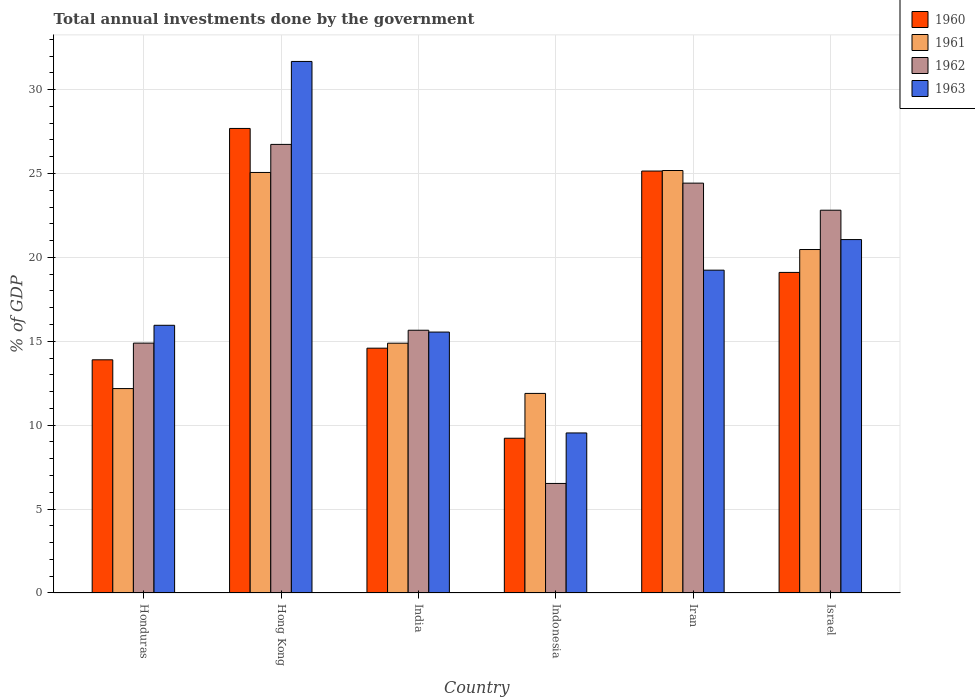How many different coloured bars are there?
Keep it short and to the point. 4. Are the number of bars per tick equal to the number of legend labels?
Give a very brief answer. Yes. Are the number of bars on each tick of the X-axis equal?
Make the answer very short. Yes. How many bars are there on the 3rd tick from the left?
Offer a terse response. 4. How many bars are there on the 1st tick from the right?
Your answer should be compact. 4. In how many cases, is the number of bars for a given country not equal to the number of legend labels?
Your response must be concise. 0. What is the total annual investments done by the government in 1962 in Iran?
Offer a very short reply. 24.43. Across all countries, what is the maximum total annual investments done by the government in 1963?
Make the answer very short. 31.68. Across all countries, what is the minimum total annual investments done by the government in 1960?
Provide a short and direct response. 9.22. In which country was the total annual investments done by the government in 1963 maximum?
Your response must be concise. Hong Kong. In which country was the total annual investments done by the government in 1963 minimum?
Provide a short and direct response. Indonesia. What is the total total annual investments done by the government in 1963 in the graph?
Offer a very short reply. 113.04. What is the difference between the total annual investments done by the government in 1961 in Iran and that in Israel?
Make the answer very short. 4.71. What is the difference between the total annual investments done by the government in 1961 in Indonesia and the total annual investments done by the government in 1960 in Honduras?
Provide a succinct answer. -2. What is the average total annual investments done by the government in 1962 per country?
Offer a terse response. 18.51. What is the difference between the total annual investments done by the government of/in 1961 and total annual investments done by the government of/in 1962 in Iran?
Offer a terse response. 0.75. What is the ratio of the total annual investments done by the government in 1962 in Honduras to that in Hong Kong?
Ensure brevity in your answer.  0.56. Is the difference between the total annual investments done by the government in 1961 in India and Indonesia greater than the difference between the total annual investments done by the government in 1962 in India and Indonesia?
Make the answer very short. No. What is the difference between the highest and the second highest total annual investments done by the government in 1962?
Provide a succinct answer. -2.31. What is the difference between the highest and the lowest total annual investments done by the government in 1963?
Make the answer very short. 22.14. Is the sum of the total annual investments done by the government in 1962 in Honduras and Hong Kong greater than the maximum total annual investments done by the government in 1963 across all countries?
Make the answer very short. Yes. Is it the case that in every country, the sum of the total annual investments done by the government in 1962 and total annual investments done by the government in 1963 is greater than the sum of total annual investments done by the government in 1961 and total annual investments done by the government in 1960?
Your response must be concise. No. Are all the bars in the graph horizontal?
Your answer should be very brief. No. How many countries are there in the graph?
Provide a short and direct response. 6. What is the difference between two consecutive major ticks on the Y-axis?
Provide a short and direct response. 5. Are the values on the major ticks of Y-axis written in scientific E-notation?
Offer a very short reply. No. Does the graph contain any zero values?
Offer a very short reply. No. Does the graph contain grids?
Provide a succinct answer. Yes. What is the title of the graph?
Offer a terse response. Total annual investments done by the government. Does "1989" appear as one of the legend labels in the graph?
Keep it short and to the point. No. What is the label or title of the X-axis?
Keep it short and to the point. Country. What is the label or title of the Y-axis?
Your answer should be very brief. % of GDP. What is the % of GDP of 1960 in Honduras?
Offer a very short reply. 13.9. What is the % of GDP in 1961 in Honduras?
Ensure brevity in your answer.  12.18. What is the % of GDP in 1962 in Honduras?
Your answer should be compact. 14.89. What is the % of GDP of 1963 in Honduras?
Provide a short and direct response. 15.96. What is the % of GDP of 1960 in Hong Kong?
Provide a short and direct response. 27.69. What is the % of GDP of 1961 in Hong Kong?
Your response must be concise. 25.06. What is the % of GDP of 1962 in Hong Kong?
Your answer should be very brief. 26.74. What is the % of GDP of 1963 in Hong Kong?
Provide a short and direct response. 31.68. What is the % of GDP of 1960 in India?
Keep it short and to the point. 14.59. What is the % of GDP of 1961 in India?
Make the answer very short. 14.89. What is the % of GDP in 1962 in India?
Make the answer very short. 15.66. What is the % of GDP of 1963 in India?
Offer a very short reply. 15.55. What is the % of GDP of 1960 in Indonesia?
Give a very brief answer. 9.22. What is the % of GDP in 1961 in Indonesia?
Keep it short and to the point. 11.9. What is the % of GDP in 1962 in Indonesia?
Your response must be concise. 6.53. What is the % of GDP in 1963 in Indonesia?
Keep it short and to the point. 9.54. What is the % of GDP in 1960 in Iran?
Make the answer very short. 25.15. What is the % of GDP in 1961 in Iran?
Provide a succinct answer. 25.18. What is the % of GDP in 1962 in Iran?
Your answer should be compact. 24.43. What is the % of GDP in 1963 in Iran?
Provide a succinct answer. 19.24. What is the % of GDP of 1960 in Israel?
Your answer should be compact. 19.11. What is the % of GDP of 1961 in Israel?
Your answer should be very brief. 20.47. What is the % of GDP in 1962 in Israel?
Your answer should be very brief. 22.82. What is the % of GDP in 1963 in Israel?
Provide a short and direct response. 21.06. Across all countries, what is the maximum % of GDP in 1960?
Your answer should be very brief. 27.69. Across all countries, what is the maximum % of GDP of 1961?
Your answer should be compact. 25.18. Across all countries, what is the maximum % of GDP in 1962?
Provide a succinct answer. 26.74. Across all countries, what is the maximum % of GDP of 1963?
Give a very brief answer. 31.68. Across all countries, what is the minimum % of GDP in 1960?
Your answer should be very brief. 9.22. Across all countries, what is the minimum % of GDP in 1961?
Provide a succinct answer. 11.9. Across all countries, what is the minimum % of GDP in 1962?
Provide a short and direct response. 6.53. Across all countries, what is the minimum % of GDP of 1963?
Offer a very short reply. 9.54. What is the total % of GDP of 1960 in the graph?
Offer a terse response. 109.66. What is the total % of GDP in 1961 in the graph?
Offer a very short reply. 109.69. What is the total % of GDP in 1962 in the graph?
Give a very brief answer. 111.07. What is the total % of GDP of 1963 in the graph?
Keep it short and to the point. 113.04. What is the difference between the % of GDP in 1960 in Honduras and that in Hong Kong?
Make the answer very short. -13.79. What is the difference between the % of GDP in 1961 in Honduras and that in Hong Kong?
Your answer should be compact. -12.88. What is the difference between the % of GDP of 1962 in Honduras and that in Hong Kong?
Your response must be concise. -11.84. What is the difference between the % of GDP of 1963 in Honduras and that in Hong Kong?
Ensure brevity in your answer.  -15.73. What is the difference between the % of GDP of 1960 in Honduras and that in India?
Provide a short and direct response. -0.69. What is the difference between the % of GDP in 1961 in Honduras and that in India?
Provide a succinct answer. -2.7. What is the difference between the % of GDP of 1962 in Honduras and that in India?
Your answer should be very brief. -0.77. What is the difference between the % of GDP of 1963 in Honduras and that in India?
Offer a very short reply. 0.4. What is the difference between the % of GDP of 1960 in Honduras and that in Indonesia?
Offer a very short reply. 4.68. What is the difference between the % of GDP in 1961 in Honduras and that in Indonesia?
Give a very brief answer. 0.29. What is the difference between the % of GDP in 1962 in Honduras and that in Indonesia?
Keep it short and to the point. 8.36. What is the difference between the % of GDP in 1963 in Honduras and that in Indonesia?
Provide a succinct answer. 6.42. What is the difference between the % of GDP of 1960 in Honduras and that in Iran?
Provide a succinct answer. -11.25. What is the difference between the % of GDP of 1961 in Honduras and that in Iran?
Keep it short and to the point. -13. What is the difference between the % of GDP of 1962 in Honduras and that in Iran?
Your answer should be very brief. -9.54. What is the difference between the % of GDP in 1963 in Honduras and that in Iran?
Your answer should be compact. -3.29. What is the difference between the % of GDP in 1960 in Honduras and that in Israel?
Provide a short and direct response. -5.21. What is the difference between the % of GDP in 1961 in Honduras and that in Israel?
Give a very brief answer. -8.29. What is the difference between the % of GDP in 1962 in Honduras and that in Israel?
Give a very brief answer. -7.92. What is the difference between the % of GDP of 1963 in Honduras and that in Israel?
Your answer should be very brief. -5.11. What is the difference between the % of GDP in 1960 in Hong Kong and that in India?
Offer a terse response. 13.1. What is the difference between the % of GDP of 1961 in Hong Kong and that in India?
Offer a very short reply. 10.18. What is the difference between the % of GDP of 1962 in Hong Kong and that in India?
Offer a terse response. 11.08. What is the difference between the % of GDP of 1963 in Hong Kong and that in India?
Your response must be concise. 16.13. What is the difference between the % of GDP of 1960 in Hong Kong and that in Indonesia?
Give a very brief answer. 18.47. What is the difference between the % of GDP of 1961 in Hong Kong and that in Indonesia?
Make the answer very short. 13.17. What is the difference between the % of GDP in 1962 in Hong Kong and that in Indonesia?
Keep it short and to the point. 20.21. What is the difference between the % of GDP in 1963 in Hong Kong and that in Indonesia?
Your response must be concise. 22.14. What is the difference between the % of GDP of 1960 in Hong Kong and that in Iran?
Keep it short and to the point. 2.54. What is the difference between the % of GDP in 1961 in Hong Kong and that in Iran?
Your answer should be very brief. -0.12. What is the difference between the % of GDP of 1962 in Hong Kong and that in Iran?
Offer a very short reply. 2.31. What is the difference between the % of GDP in 1963 in Hong Kong and that in Iran?
Your answer should be compact. 12.44. What is the difference between the % of GDP of 1960 in Hong Kong and that in Israel?
Provide a short and direct response. 8.58. What is the difference between the % of GDP in 1961 in Hong Kong and that in Israel?
Keep it short and to the point. 4.59. What is the difference between the % of GDP of 1962 in Hong Kong and that in Israel?
Provide a succinct answer. 3.92. What is the difference between the % of GDP of 1963 in Hong Kong and that in Israel?
Your answer should be very brief. 10.62. What is the difference between the % of GDP of 1960 in India and that in Indonesia?
Make the answer very short. 5.37. What is the difference between the % of GDP in 1961 in India and that in Indonesia?
Provide a succinct answer. 2.99. What is the difference between the % of GDP in 1962 in India and that in Indonesia?
Provide a short and direct response. 9.13. What is the difference between the % of GDP of 1963 in India and that in Indonesia?
Keep it short and to the point. 6.01. What is the difference between the % of GDP in 1960 in India and that in Iran?
Give a very brief answer. -10.56. What is the difference between the % of GDP in 1961 in India and that in Iran?
Keep it short and to the point. -10.29. What is the difference between the % of GDP of 1962 in India and that in Iran?
Provide a short and direct response. -8.77. What is the difference between the % of GDP in 1963 in India and that in Iran?
Offer a very short reply. -3.69. What is the difference between the % of GDP in 1960 in India and that in Israel?
Your response must be concise. -4.52. What is the difference between the % of GDP in 1961 in India and that in Israel?
Provide a short and direct response. -5.58. What is the difference between the % of GDP of 1962 in India and that in Israel?
Offer a very short reply. -7.15. What is the difference between the % of GDP of 1963 in India and that in Israel?
Provide a short and direct response. -5.51. What is the difference between the % of GDP of 1960 in Indonesia and that in Iran?
Ensure brevity in your answer.  -15.93. What is the difference between the % of GDP of 1961 in Indonesia and that in Iran?
Offer a very short reply. -13.29. What is the difference between the % of GDP of 1962 in Indonesia and that in Iran?
Your response must be concise. -17.9. What is the difference between the % of GDP of 1963 in Indonesia and that in Iran?
Ensure brevity in your answer.  -9.7. What is the difference between the % of GDP of 1960 in Indonesia and that in Israel?
Offer a very short reply. -9.88. What is the difference between the % of GDP of 1961 in Indonesia and that in Israel?
Provide a succinct answer. -8.58. What is the difference between the % of GDP in 1962 in Indonesia and that in Israel?
Your answer should be compact. -16.29. What is the difference between the % of GDP in 1963 in Indonesia and that in Israel?
Your answer should be compact. -11.53. What is the difference between the % of GDP of 1960 in Iran and that in Israel?
Keep it short and to the point. 6.04. What is the difference between the % of GDP in 1961 in Iran and that in Israel?
Ensure brevity in your answer.  4.71. What is the difference between the % of GDP in 1962 in Iran and that in Israel?
Make the answer very short. 1.61. What is the difference between the % of GDP of 1963 in Iran and that in Israel?
Ensure brevity in your answer.  -1.82. What is the difference between the % of GDP in 1960 in Honduras and the % of GDP in 1961 in Hong Kong?
Offer a very short reply. -11.17. What is the difference between the % of GDP in 1960 in Honduras and the % of GDP in 1962 in Hong Kong?
Your answer should be compact. -12.84. What is the difference between the % of GDP in 1960 in Honduras and the % of GDP in 1963 in Hong Kong?
Ensure brevity in your answer.  -17.78. What is the difference between the % of GDP of 1961 in Honduras and the % of GDP of 1962 in Hong Kong?
Make the answer very short. -14.55. What is the difference between the % of GDP of 1961 in Honduras and the % of GDP of 1963 in Hong Kong?
Provide a short and direct response. -19.5. What is the difference between the % of GDP in 1962 in Honduras and the % of GDP in 1963 in Hong Kong?
Offer a very short reply. -16.79. What is the difference between the % of GDP in 1960 in Honduras and the % of GDP in 1961 in India?
Provide a succinct answer. -0.99. What is the difference between the % of GDP in 1960 in Honduras and the % of GDP in 1962 in India?
Give a very brief answer. -1.76. What is the difference between the % of GDP in 1960 in Honduras and the % of GDP in 1963 in India?
Offer a terse response. -1.65. What is the difference between the % of GDP in 1961 in Honduras and the % of GDP in 1962 in India?
Ensure brevity in your answer.  -3.48. What is the difference between the % of GDP in 1961 in Honduras and the % of GDP in 1963 in India?
Your answer should be compact. -3.37. What is the difference between the % of GDP in 1962 in Honduras and the % of GDP in 1963 in India?
Ensure brevity in your answer.  -0.66. What is the difference between the % of GDP in 1960 in Honduras and the % of GDP in 1961 in Indonesia?
Make the answer very short. 2. What is the difference between the % of GDP of 1960 in Honduras and the % of GDP of 1962 in Indonesia?
Offer a terse response. 7.37. What is the difference between the % of GDP of 1960 in Honduras and the % of GDP of 1963 in Indonesia?
Provide a succinct answer. 4.36. What is the difference between the % of GDP in 1961 in Honduras and the % of GDP in 1962 in Indonesia?
Provide a short and direct response. 5.65. What is the difference between the % of GDP in 1961 in Honduras and the % of GDP in 1963 in Indonesia?
Your answer should be compact. 2.64. What is the difference between the % of GDP in 1962 in Honduras and the % of GDP in 1963 in Indonesia?
Ensure brevity in your answer.  5.35. What is the difference between the % of GDP in 1960 in Honduras and the % of GDP in 1961 in Iran?
Your answer should be compact. -11.28. What is the difference between the % of GDP in 1960 in Honduras and the % of GDP in 1962 in Iran?
Offer a terse response. -10.53. What is the difference between the % of GDP of 1960 in Honduras and the % of GDP of 1963 in Iran?
Ensure brevity in your answer.  -5.34. What is the difference between the % of GDP of 1961 in Honduras and the % of GDP of 1962 in Iran?
Keep it short and to the point. -12.24. What is the difference between the % of GDP of 1961 in Honduras and the % of GDP of 1963 in Iran?
Your response must be concise. -7.06. What is the difference between the % of GDP in 1962 in Honduras and the % of GDP in 1963 in Iran?
Make the answer very short. -4.35. What is the difference between the % of GDP in 1960 in Honduras and the % of GDP in 1961 in Israel?
Make the answer very short. -6.57. What is the difference between the % of GDP of 1960 in Honduras and the % of GDP of 1962 in Israel?
Offer a terse response. -8.92. What is the difference between the % of GDP in 1960 in Honduras and the % of GDP in 1963 in Israel?
Provide a short and direct response. -7.17. What is the difference between the % of GDP of 1961 in Honduras and the % of GDP of 1962 in Israel?
Offer a terse response. -10.63. What is the difference between the % of GDP in 1961 in Honduras and the % of GDP in 1963 in Israel?
Give a very brief answer. -8.88. What is the difference between the % of GDP of 1962 in Honduras and the % of GDP of 1963 in Israel?
Your answer should be compact. -6.17. What is the difference between the % of GDP in 1960 in Hong Kong and the % of GDP in 1961 in India?
Your answer should be compact. 12.8. What is the difference between the % of GDP of 1960 in Hong Kong and the % of GDP of 1962 in India?
Offer a very short reply. 12.03. What is the difference between the % of GDP in 1960 in Hong Kong and the % of GDP in 1963 in India?
Offer a terse response. 12.14. What is the difference between the % of GDP of 1961 in Hong Kong and the % of GDP of 1962 in India?
Offer a terse response. 9.4. What is the difference between the % of GDP in 1961 in Hong Kong and the % of GDP in 1963 in India?
Your answer should be compact. 9.51. What is the difference between the % of GDP in 1962 in Hong Kong and the % of GDP in 1963 in India?
Provide a short and direct response. 11.19. What is the difference between the % of GDP in 1960 in Hong Kong and the % of GDP in 1961 in Indonesia?
Provide a short and direct response. 15.79. What is the difference between the % of GDP in 1960 in Hong Kong and the % of GDP in 1962 in Indonesia?
Keep it short and to the point. 21.16. What is the difference between the % of GDP of 1960 in Hong Kong and the % of GDP of 1963 in Indonesia?
Your answer should be very brief. 18.15. What is the difference between the % of GDP in 1961 in Hong Kong and the % of GDP in 1962 in Indonesia?
Provide a succinct answer. 18.54. What is the difference between the % of GDP of 1961 in Hong Kong and the % of GDP of 1963 in Indonesia?
Your answer should be compact. 15.53. What is the difference between the % of GDP in 1962 in Hong Kong and the % of GDP in 1963 in Indonesia?
Provide a succinct answer. 17.2. What is the difference between the % of GDP of 1960 in Hong Kong and the % of GDP of 1961 in Iran?
Give a very brief answer. 2.51. What is the difference between the % of GDP in 1960 in Hong Kong and the % of GDP in 1962 in Iran?
Provide a succinct answer. 3.26. What is the difference between the % of GDP in 1960 in Hong Kong and the % of GDP in 1963 in Iran?
Your answer should be compact. 8.45. What is the difference between the % of GDP in 1961 in Hong Kong and the % of GDP in 1962 in Iran?
Your answer should be compact. 0.64. What is the difference between the % of GDP of 1961 in Hong Kong and the % of GDP of 1963 in Iran?
Your answer should be very brief. 5.82. What is the difference between the % of GDP in 1962 in Hong Kong and the % of GDP in 1963 in Iran?
Ensure brevity in your answer.  7.5. What is the difference between the % of GDP of 1960 in Hong Kong and the % of GDP of 1961 in Israel?
Your answer should be compact. 7.22. What is the difference between the % of GDP of 1960 in Hong Kong and the % of GDP of 1962 in Israel?
Make the answer very short. 4.87. What is the difference between the % of GDP in 1960 in Hong Kong and the % of GDP in 1963 in Israel?
Give a very brief answer. 6.62. What is the difference between the % of GDP of 1961 in Hong Kong and the % of GDP of 1962 in Israel?
Provide a short and direct response. 2.25. What is the difference between the % of GDP in 1961 in Hong Kong and the % of GDP in 1963 in Israel?
Give a very brief answer. 4. What is the difference between the % of GDP of 1962 in Hong Kong and the % of GDP of 1963 in Israel?
Offer a very short reply. 5.67. What is the difference between the % of GDP of 1960 in India and the % of GDP of 1961 in Indonesia?
Ensure brevity in your answer.  2.7. What is the difference between the % of GDP in 1960 in India and the % of GDP in 1962 in Indonesia?
Ensure brevity in your answer.  8.06. What is the difference between the % of GDP of 1960 in India and the % of GDP of 1963 in Indonesia?
Provide a short and direct response. 5.05. What is the difference between the % of GDP in 1961 in India and the % of GDP in 1962 in Indonesia?
Provide a succinct answer. 8.36. What is the difference between the % of GDP of 1961 in India and the % of GDP of 1963 in Indonesia?
Provide a succinct answer. 5.35. What is the difference between the % of GDP in 1962 in India and the % of GDP in 1963 in Indonesia?
Make the answer very short. 6.12. What is the difference between the % of GDP in 1960 in India and the % of GDP in 1961 in Iran?
Your response must be concise. -10.59. What is the difference between the % of GDP in 1960 in India and the % of GDP in 1962 in Iran?
Offer a very short reply. -9.84. What is the difference between the % of GDP in 1960 in India and the % of GDP in 1963 in Iran?
Your response must be concise. -4.65. What is the difference between the % of GDP of 1961 in India and the % of GDP of 1962 in Iran?
Ensure brevity in your answer.  -9.54. What is the difference between the % of GDP in 1961 in India and the % of GDP in 1963 in Iran?
Offer a terse response. -4.35. What is the difference between the % of GDP in 1962 in India and the % of GDP in 1963 in Iran?
Provide a short and direct response. -3.58. What is the difference between the % of GDP in 1960 in India and the % of GDP in 1961 in Israel?
Offer a terse response. -5.88. What is the difference between the % of GDP in 1960 in India and the % of GDP in 1962 in Israel?
Your answer should be very brief. -8.22. What is the difference between the % of GDP of 1960 in India and the % of GDP of 1963 in Israel?
Give a very brief answer. -6.47. What is the difference between the % of GDP of 1961 in India and the % of GDP of 1962 in Israel?
Provide a short and direct response. -7.93. What is the difference between the % of GDP in 1961 in India and the % of GDP in 1963 in Israel?
Ensure brevity in your answer.  -6.18. What is the difference between the % of GDP in 1962 in India and the % of GDP in 1963 in Israel?
Offer a very short reply. -5.4. What is the difference between the % of GDP of 1960 in Indonesia and the % of GDP of 1961 in Iran?
Your answer should be compact. -15.96. What is the difference between the % of GDP in 1960 in Indonesia and the % of GDP in 1962 in Iran?
Provide a short and direct response. -15.21. What is the difference between the % of GDP of 1960 in Indonesia and the % of GDP of 1963 in Iran?
Your answer should be very brief. -10.02. What is the difference between the % of GDP of 1961 in Indonesia and the % of GDP of 1962 in Iran?
Your response must be concise. -12.53. What is the difference between the % of GDP in 1961 in Indonesia and the % of GDP in 1963 in Iran?
Offer a very short reply. -7.35. What is the difference between the % of GDP in 1962 in Indonesia and the % of GDP in 1963 in Iran?
Keep it short and to the point. -12.71. What is the difference between the % of GDP in 1960 in Indonesia and the % of GDP in 1961 in Israel?
Offer a very short reply. -11.25. What is the difference between the % of GDP of 1960 in Indonesia and the % of GDP of 1962 in Israel?
Your answer should be compact. -13.59. What is the difference between the % of GDP of 1960 in Indonesia and the % of GDP of 1963 in Israel?
Provide a short and direct response. -11.84. What is the difference between the % of GDP of 1961 in Indonesia and the % of GDP of 1962 in Israel?
Ensure brevity in your answer.  -10.92. What is the difference between the % of GDP in 1961 in Indonesia and the % of GDP in 1963 in Israel?
Offer a very short reply. -9.17. What is the difference between the % of GDP in 1962 in Indonesia and the % of GDP in 1963 in Israel?
Provide a short and direct response. -14.54. What is the difference between the % of GDP in 1960 in Iran and the % of GDP in 1961 in Israel?
Provide a succinct answer. 4.68. What is the difference between the % of GDP of 1960 in Iran and the % of GDP of 1962 in Israel?
Give a very brief answer. 2.33. What is the difference between the % of GDP of 1960 in Iran and the % of GDP of 1963 in Israel?
Provide a succinct answer. 4.08. What is the difference between the % of GDP of 1961 in Iran and the % of GDP of 1962 in Israel?
Your answer should be very brief. 2.37. What is the difference between the % of GDP of 1961 in Iran and the % of GDP of 1963 in Israel?
Your answer should be compact. 4.12. What is the difference between the % of GDP in 1962 in Iran and the % of GDP in 1963 in Israel?
Give a very brief answer. 3.36. What is the average % of GDP in 1960 per country?
Provide a succinct answer. 18.28. What is the average % of GDP in 1961 per country?
Offer a terse response. 18.28. What is the average % of GDP in 1962 per country?
Your response must be concise. 18.51. What is the average % of GDP of 1963 per country?
Provide a succinct answer. 18.84. What is the difference between the % of GDP in 1960 and % of GDP in 1961 in Honduras?
Keep it short and to the point. 1.71. What is the difference between the % of GDP in 1960 and % of GDP in 1962 in Honduras?
Ensure brevity in your answer.  -1. What is the difference between the % of GDP in 1960 and % of GDP in 1963 in Honduras?
Give a very brief answer. -2.06. What is the difference between the % of GDP in 1961 and % of GDP in 1962 in Honduras?
Offer a terse response. -2.71. What is the difference between the % of GDP of 1961 and % of GDP of 1963 in Honduras?
Offer a very short reply. -3.77. What is the difference between the % of GDP of 1962 and % of GDP of 1963 in Honduras?
Your answer should be very brief. -1.06. What is the difference between the % of GDP in 1960 and % of GDP in 1961 in Hong Kong?
Provide a short and direct response. 2.62. What is the difference between the % of GDP in 1960 and % of GDP in 1962 in Hong Kong?
Your answer should be very brief. 0.95. What is the difference between the % of GDP of 1960 and % of GDP of 1963 in Hong Kong?
Keep it short and to the point. -3.99. What is the difference between the % of GDP of 1961 and % of GDP of 1962 in Hong Kong?
Ensure brevity in your answer.  -1.67. What is the difference between the % of GDP in 1961 and % of GDP in 1963 in Hong Kong?
Provide a short and direct response. -6.62. What is the difference between the % of GDP of 1962 and % of GDP of 1963 in Hong Kong?
Your answer should be very brief. -4.94. What is the difference between the % of GDP of 1960 and % of GDP of 1961 in India?
Offer a very short reply. -0.3. What is the difference between the % of GDP of 1960 and % of GDP of 1962 in India?
Keep it short and to the point. -1.07. What is the difference between the % of GDP of 1960 and % of GDP of 1963 in India?
Keep it short and to the point. -0.96. What is the difference between the % of GDP in 1961 and % of GDP in 1962 in India?
Give a very brief answer. -0.77. What is the difference between the % of GDP in 1961 and % of GDP in 1963 in India?
Your response must be concise. -0.66. What is the difference between the % of GDP in 1962 and % of GDP in 1963 in India?
Keep it short and to the point. 0.11. What is the difference between the % of GDP of 1960 and % of GDP of 1961 in Indonesia?
Provide a succinct answer. -2.67. What is the difference between the % of GDP of 1960 and % of GDP of 1962 in Indonesia?
Your answer should be very brief. 2.69. What is the difference between the % of GDP in 1960 and % of GDP in 1963 in Indonesia?
Offer a very short reply. -0.32. What is the difference between the % of GDP of 1961 and % of GDP of 1962 in Indonesia?
Keep it short and to the point. 5.37. What is the difference between the % of GDP in 1961 and % of GDP in 1963 in Indonesia?
Offer a terse response. 2.36. What is the difference between the % of GDP in 1962 and % of GDP in 1963 in Indonesia?
Offer a very short reply. -3.01. What is the difference between the % of GDP of 1960 and % of GDP of 1961 in Iran?
Your answer should be compact. -0.03. What is the difference between the % of GDP of 1960 and % of GDP of 1962 in Iran?
Keep it short and to the point. 0.72. What is the difference between the % of GDP of 1960 and % of GDP of 1963 in Iran?
Offer a terse response. 5.91. What is the difference between the % of GDP of 1961 and % of GDP of 1962 in Iran?
Your answer should be compact. 0.75. What is the difference between the % of GDP of 1961 and % of GDP of 1963 in Iran?
Ensure brevity in your answer.  5.94. What is the difference between the % of GDP in 1962 and % of GDP in 1963 in Iran?
Provide a succinct answer. 5.19. What is the difference between the % of GDP in 1960 and % of GDP in 1961 in Israel?
Make the answer very short. -1.36. What is the difference between the % of GDP in 1960 and % of GDP in 1962 in Israel?
Offer a very short reply. -3.71. What is the difference between the % of GDP in 1960 and % of GDP in 1963 in Israel?
Offer a very short reply. -1.96. What is the difference between the % of GDP in 1961 and % of GDP in 1962 in Israel?
Offer a terse response. -2.34. What is the difference between the % of GDP of 1961 and % of GDP of 1963 in Israel?
Offer a very short reply. -0.59. What is the difference between the % of GDP in 1962 and % of GDP in 1963 in Israel?
Make the answer very short. 1.75. What is the ratio of the % of GDP in 1960 in Honduras to that in Hong Kong?
Your answer should be compact. 0.5. What is the ratio of the % of GDP in 1961 in Honduras to that in Hong Kong?
Keep it short and to the point. 0.49. What is the ratio of the % of GDP of 1962 in Honduras to that in Hong Kong?
Your response must be concise. 0.56. What is the ratio of the % of GDP in 1963 in Honduras to that in Hong Kong?
Provide a succinct answer. 0.5. What is the ratio of the % of GDP of 1960 in Honduras to that in India?
Ensure brevity in your answer.  0.95. What is the ratio of the % of GDP of 1961 in Honduras to that in India?
Provide a short and direct response. 0.82. What is the ratio of the % of GDP of 1962 in Honduras to that in India?
Your answer should be compact. 0.95. What is the ratio of the % of GDP of 1963 in Honduras to that in India?
Your answer should be very brief. 1.03. What is the ratio of the % of GDP of 1960 in Honduras to that in Indonesia?
Offer a very short reply. 1.51. What is the ratio of the % of GDP in 1961 in Honduras to that in Indonesia?
Ensure brevity in your answer.  1.02. What is the ratio of the % of GDP in 1962 in Honduras to that in Indonesia?
Provide a succinct answer. 2.28. What is the ratio of the % of GDP in 1963 in Honduras to that in Indonesia?
Give a very brief answer. 1.67. What is the ratio of the % of GDP in 1960 in Honduras to that in Iran?
Your response must be concise. 0.55. What is the ratio of the % of GDP in 1961 in Honduras to that in Iran?
Provide a succinct answer. 0.48. What is the ratio of the % of GDP of 1962 in Honduras to that in Iran?
Keep it short and to the point. 0.61. What is the ratio of the % of GDP of 1963 in Honduras to that in Iran?
Ensure brevity in your answer.  0.83. What is the ratio of the % of GDP in 1960 in Honduras to that in Israel?
Keep it short and to the point. 0.73. What is the ratio of the % of GDP in 1961 in Honduras to that in Israel?
Your response must be concise. 0.6. What is the ratio of the % of GDP in 1962 in Honduras to that in Israel?
Provide a succinct answer. 0.65. What is the ratio of the % of GDP in 1963 in Honduras to that in Israel?
Offer a terse response. 0.76. What is the ratio of the % of GDP of 1960 in Hong Kong to that in India?
Your response must be concise. 1.9. What is the ratio of the % of GDP of 1961 in Hong Kong to that in India?
Provide a short and direct response. 1.68. What is the ratio of the % of GDP of 1962 in Hong Kong to that in India?
Provide a short and direct response. 1.71. What is the ratio of the % of GDP in 1963 in Hong Kong to that in India?
Provide a short and direct response. 2.04. What is the ratio of the % of GDP of 1960 in Hong Kong to that in Indonesia?
Your answer should be compact. 3. What is the ratio of the % of GDP of 1961 in Hong Kong to that in Indonesia?
Provide a succinct answer. 2.11. What is the ratio of the % of GDP of 1962 in Hong Kong to that in Indonesia?
Your answer should be compact. 4.09. What is the ratio of the % of GDP in 1963 in Hong Kong to that in Indonesia?
Ensure brevity in your answer.  3.32. What is the ratio of the % of GDP of 1960 in Hong Kong to that in Iran?
Your answer should be very brief. 1.1. What is the ratio of the % of GDP in 1962 in Hong Kong to that in Iran?
Provide a short and direct response. 1.09. What is the ratio of the % of GDP of 1963 in Hong Kong to that in Iran?
Provide a short and direct response. 1.65. What is the ratio of the % of GDP of 1960 in Hong Kong to that in Israel?
Provide a succinct answer. 1.45. What is the ratio of the % of GDP of 1961 in Hong Kong to that in Israel?
Provide a succinct answer. 1.22. What is the ratio of the % of GDP of 1962 in Hong Kong to that in Israel?
Provide a succinct answer. 1.17. What is the ratio of the % of GDP in 1963 in Hong Kong to that in Israel?
Keep it short and to the point. 1.5. What is the ratio of the % of GDP of 1960 in India to that in Indonesia?
Your response must be concise. 1.58. What is the ratio of the % of GDP in 1961 in India to that in Indonesia?
Offer a terse response. 1.25. What is the ratio of the % of GDP in 1962 in India to that in Indonesia?
Your response must be concise. 2.4. What is the ratio of the % of GDP in 1963 in India to that in Indonesia?
Give a very brief answer. 1.63. What is the ratio of the % of GDP of 1960 in India to that in Iran?
Keep it short and to the point. 0.58. What is the ratio of the % of GDP in 1961 in India to that in Iran?
Provide a short and direct response. 0.59. What is the ratio of the % of GDP of 1962 in India to that in Iran?
Your answer should be very brief. 0.64. What is the ratio of the % of GDP of 1963 in India to that in Iran?
Your answer should be compact. 0.81. What is the ratio of the % of GDP of 1960 in India to that in Israel?
Your answer should be very brief. 0.76. What is the ratio of the % of GDP in 1961 in India to that in Israel?
Offer a very short reply. 0.73. What is the ratio of the % of GDP of 1962 in India to that in Israel?
Ensure brevity in your answer.  0.69. What is the ratio of the % of GDP in 1963 in India to that in Israel?
Your answer should be compact. 0.74. What is the ratio of the % of GDP of 1960 in Indonesia to that in Iran?
Your answer should be compact. 0.37. What is the ratio of the % of GDP of 1961 in Indonesia to that in Iran?
Ensure brevity in your answer.  0.47. What is the ratio of the % of GDP of 1962 in Indonesia to that in Iran?
Your answer should be very brief. 0.27. What is the ratio of the % of GDP of 1963 in Indonesia to that in Iran?
Provide a succinct answer. 0.5. What is the ratio of the % of GDP in 1960 in Indonesia to that in Israel?
Give a very brief answer. 0.48. What is the ratio of the % of GDP of 1961 in Indonesia to that in Israel?
Give a very brief answer. 0.58. What is the ratio of the % of GDP of 1962 in Indonesia to that in Israel?
Your answer should be very brief. 0.29. What is the ratio of the % of GDP of 1963 in Indonesia to that in Israel?
Your response must be concise. 0.45. What is the ratio of the % of GDP in 1960 in Iran to that in Israel?
Give a very brief answer. 1.32. What is the ratio of the % of GDP of 1961 in Iran to that in Israel?
Offer a terse response. 1.23. What is the ratio of the % of GDP of 1962 in Iran to that in Israel?
Provide a short and direct response. 1.07. What is the ratio of the % of GDP of 1963 in Iran to that in Israel?
Your answer should be very brief. 0.91. What is the difference between the highest and the second highest % of GDP of 1960?
Provide a short and direct response. 2.54. What is the difference between the highest and the second highest % of GDP in 1961?
Give a very brief answer. 0.12. What is the difference between the highest and the second highest % of GDP in 1962?
Your answer should be very brief. 2.31. What is the difference between the highest and the second highest % of GDP of 1963?
Offer a terse response. 10.62. What is the difference between the highest and the lowest % of GDP of 1960?
Give a very brief answer. 18.47. What is the difference between the highest and the lowest % of GDP in 1961?
Ensure brevity in your answer.  13.29. What is the difference between the highest and the lowest % of GDP in 1962?
Provide a succinct answer. 20.21. What is the difference between the highest and the lowest % of GDP of 1963?
Keep it short and to the point. 22.14. 